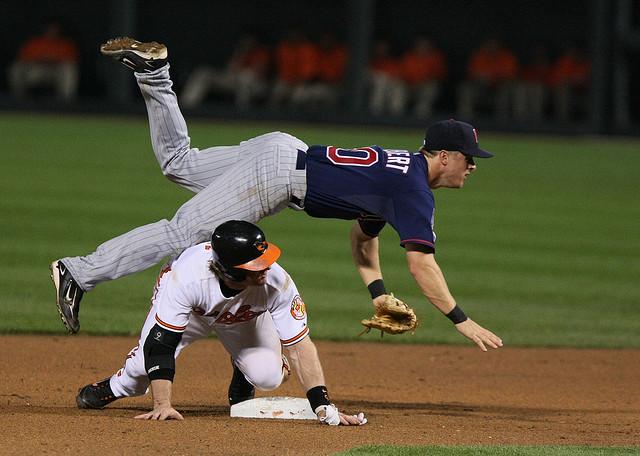Is the player safe?
Answer briefly. Yes. What two teams is this?
Write a very short answer. Baseball. What sport is this?
Answer briefly. Baseball. How many feet aren't touching the ground?
Answer briefly. 2. Is the batter safe?
Give a very brief answer. Yes. What number is the player sliding?
Give a very brief answer. 0. 